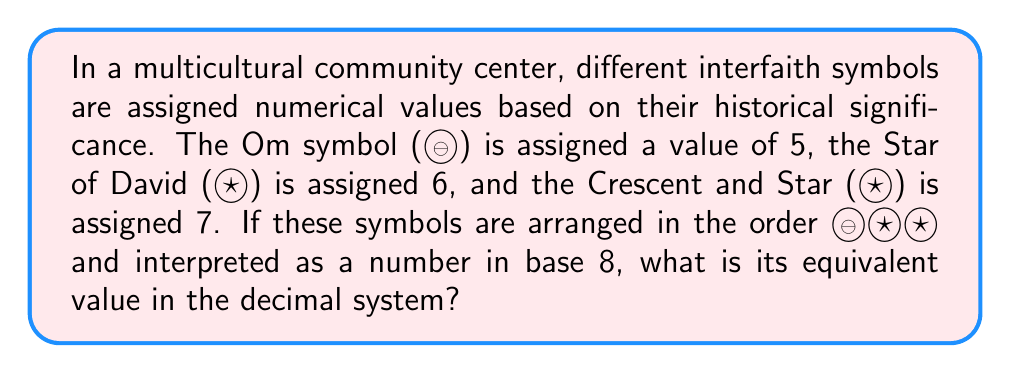Can you answer this question? To solve this problem, we need to understand positional notation and convert from base-8 to base-10. Let's break it down step-by-step:

1) In the given arrangement ☸✡☪, we have:
   ☸ in the hundreds place (base-8)
   ✡ in the tens place (base-8)
   ☪ in the ones place (base-8)

2) We know that:
   ☸ = 5
   ✡ = 6
   ☪ = 7

3) In base-8, each position represents a power of 8. So, we can write our number as:

   $5 \times 8^2 + 6 \times 8^1 + 7 \times 8^0$

4) Let's calculate each term:
   $5 \times 8^2 = 5 \times 64 = 320$
   $6 \times 8^1 = 6 \times 8 = 48$
   $7 \times 8^0 = 7 \times 1 = 7$

5) Now, we sum these values:

   $320 + 48 + 7 = 375$

Therefore, the base-8 number ☸✡☪ is equivalent to 375 in the decimal system.
Answer: 375 